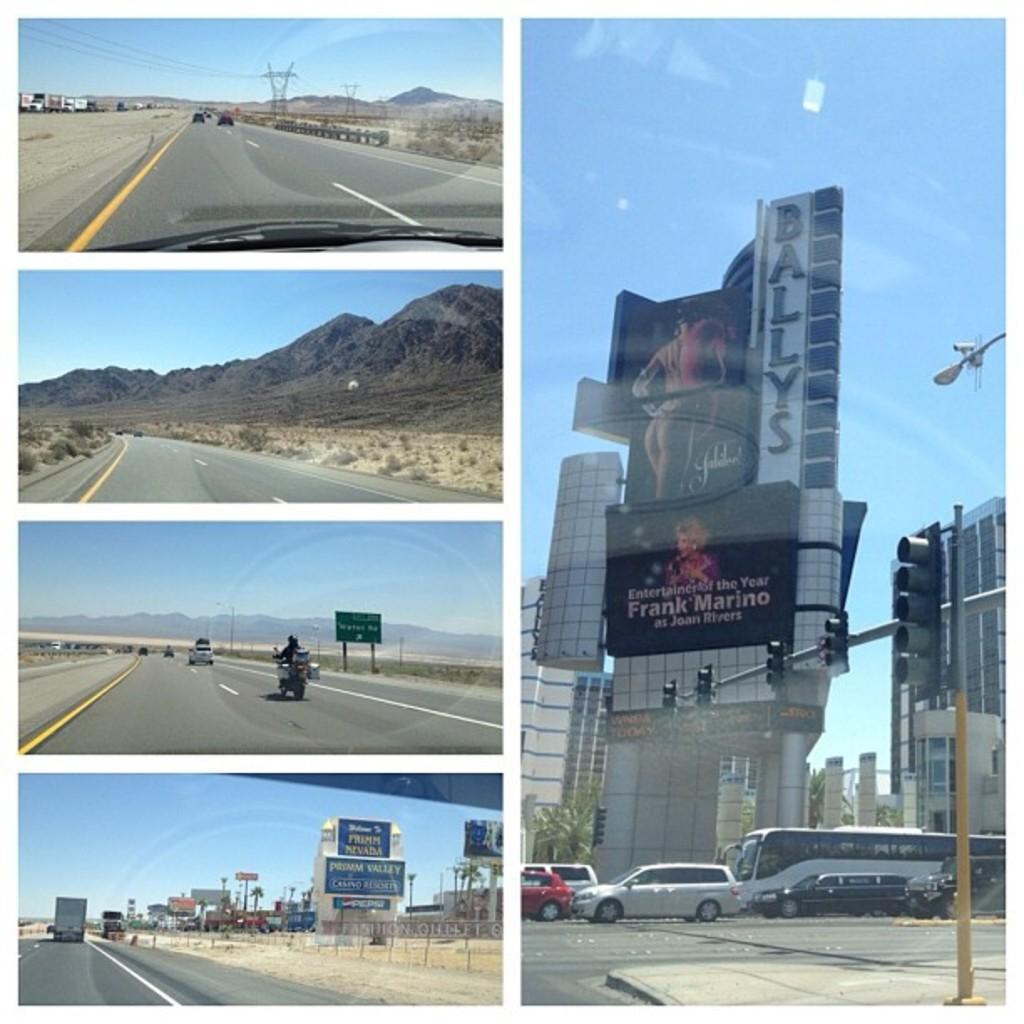Can you describe this image briefly? This is an edited collage image , where there are vehicles on the road, there are buildings, trees, hills, signal lights and boards attached to the poles, there are cell towers, and in the background there is sky. 